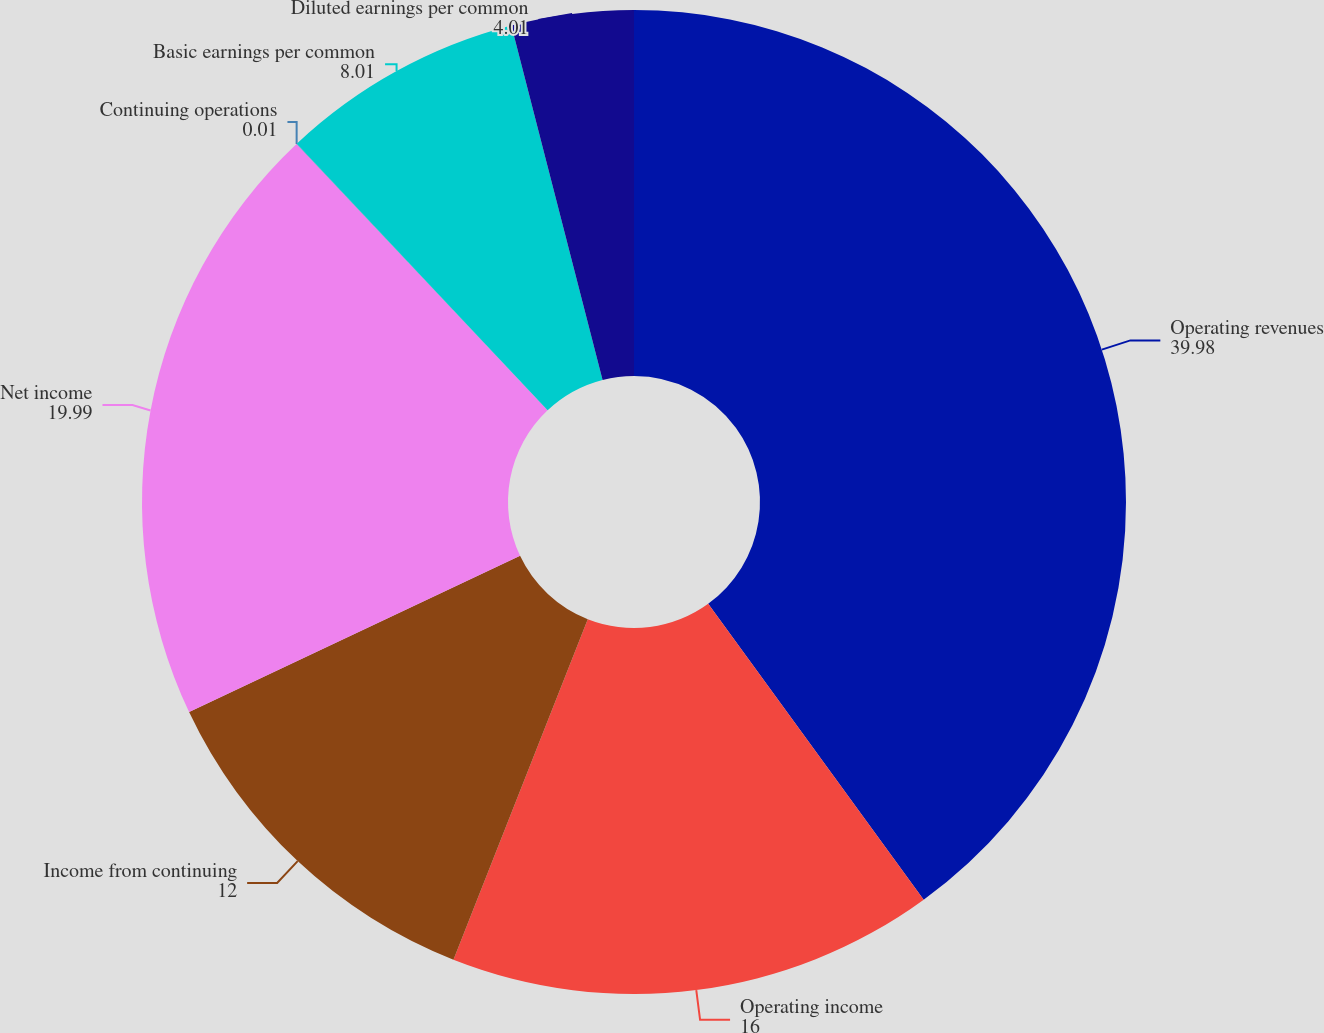Convert chart. <chart><loc_0><loc_0><loc_500><loc_500><pie_chart><fcel>Operating revenues<fcel>Operating income<fcel>Income from continuing<fcel>Net income<fcel>Continuing operations<fcel>Basic earnings per common<fcel>Diluted earnings per common<nl><fcel>39.98%<fcel>16.0%<fcel>12.0%<fcel>19.99%<fcel>0.01%<fcel>8.01%<fcel>4.01%<nl></chart> 